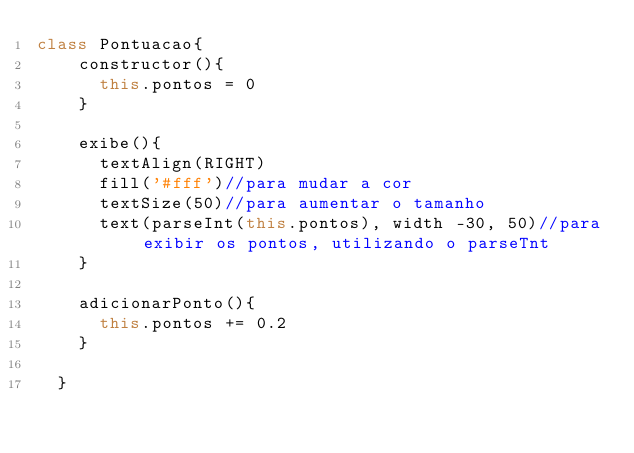<code> <loc_0><loc_0><loc_500><loc_500><_JavaScript_>class Pontuacao{
    constructor(){
      this.pontos = 0
    }
    
    exibe(){
      textAlign(RIGHT)
      fill('#fff')//para mudar a cor
      textSize(50)//para aumentar o tamanho
      text(parseInt(this.pontos), width -30, 50)//para exibir os pontos, utilizando o parseTnt
    }
    
    adicionarPonto(){
      this.pontos += 0.2
    }
  
  }</code> 